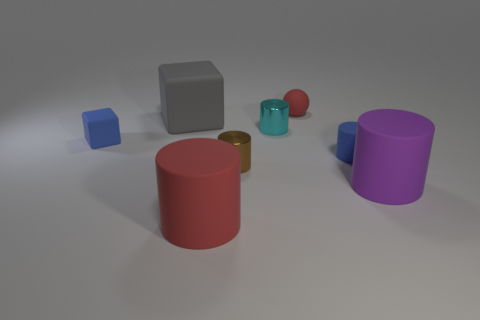Are any tiny red balls visible?
Your answer should be very brief. Yes. Does the red thing behind the large cube have the same material as the blue cylinder?
Keep it short and to the point. Yes. The rubber cylinder that is the same color as the small rubber sphere is what size?
Offer a terse response. Large. What number of matte cubes have the same size as the brown thing?
Offer a very short reply. 1. Are there an equal number of large rubber cylinders on the right side of the brown shiny thing and blue cubes?
Offer a terse response. Yes. How many objects are to the right of the blue rubber cylinder and on the left side of the big block?
Your answer should be very brief. 0. There is a ball that is the same material as the purple cylinder; what is its size?
Offer a terse response. Small. How many other small rubber objects are the same shape as the brown object?
Your response must be concise. 1. Are there more big matte objects that are to the left of the purple matte thing than big blue shiny cubes?
Provide a succinct answer. Yes. The large matte object that is both left of the purple rubber cylinder and in front of the gray rubber object has what shape?
Offer a very short reply. Cylinder. 